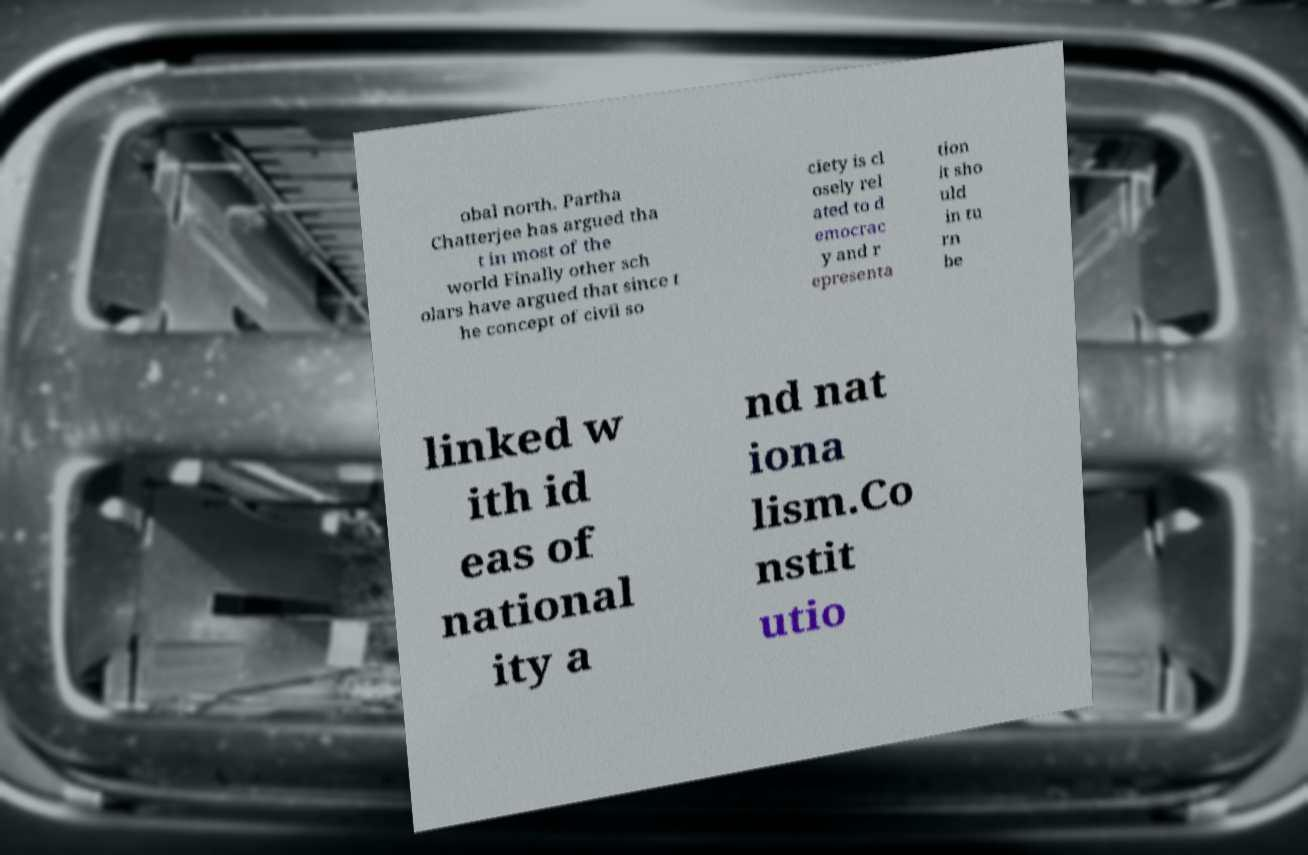I need the written content from this picture converted into text. Can you do that? obal north. Partha Chatterjee has argued tha t in most of the world Finally other sch olars have argued that since t he concept of civil so ciety is cl osely rel ated to d emocrac y and r epresenta tion it sho uld in tu rn be linked w ith id eas of national ity a nd nat iona lism.Co nstit utio 